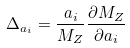Convert formula to latex. <formula><loc_0><loc_0><loc_500><loc_500>\Delta _ { a _ { i } } = { \frac { a _ { i } } { M _ { Z } } } { \frac { \partial M _ { Z } } { \partial a _ { i } } }</formula> 